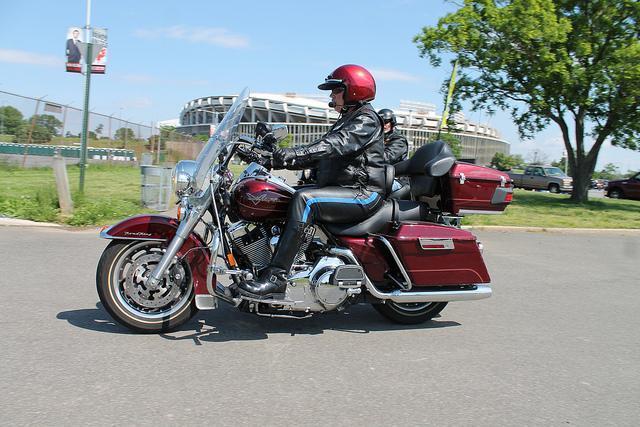How many crotch rockets are in this picture?
Give a very brief answer. 0. 